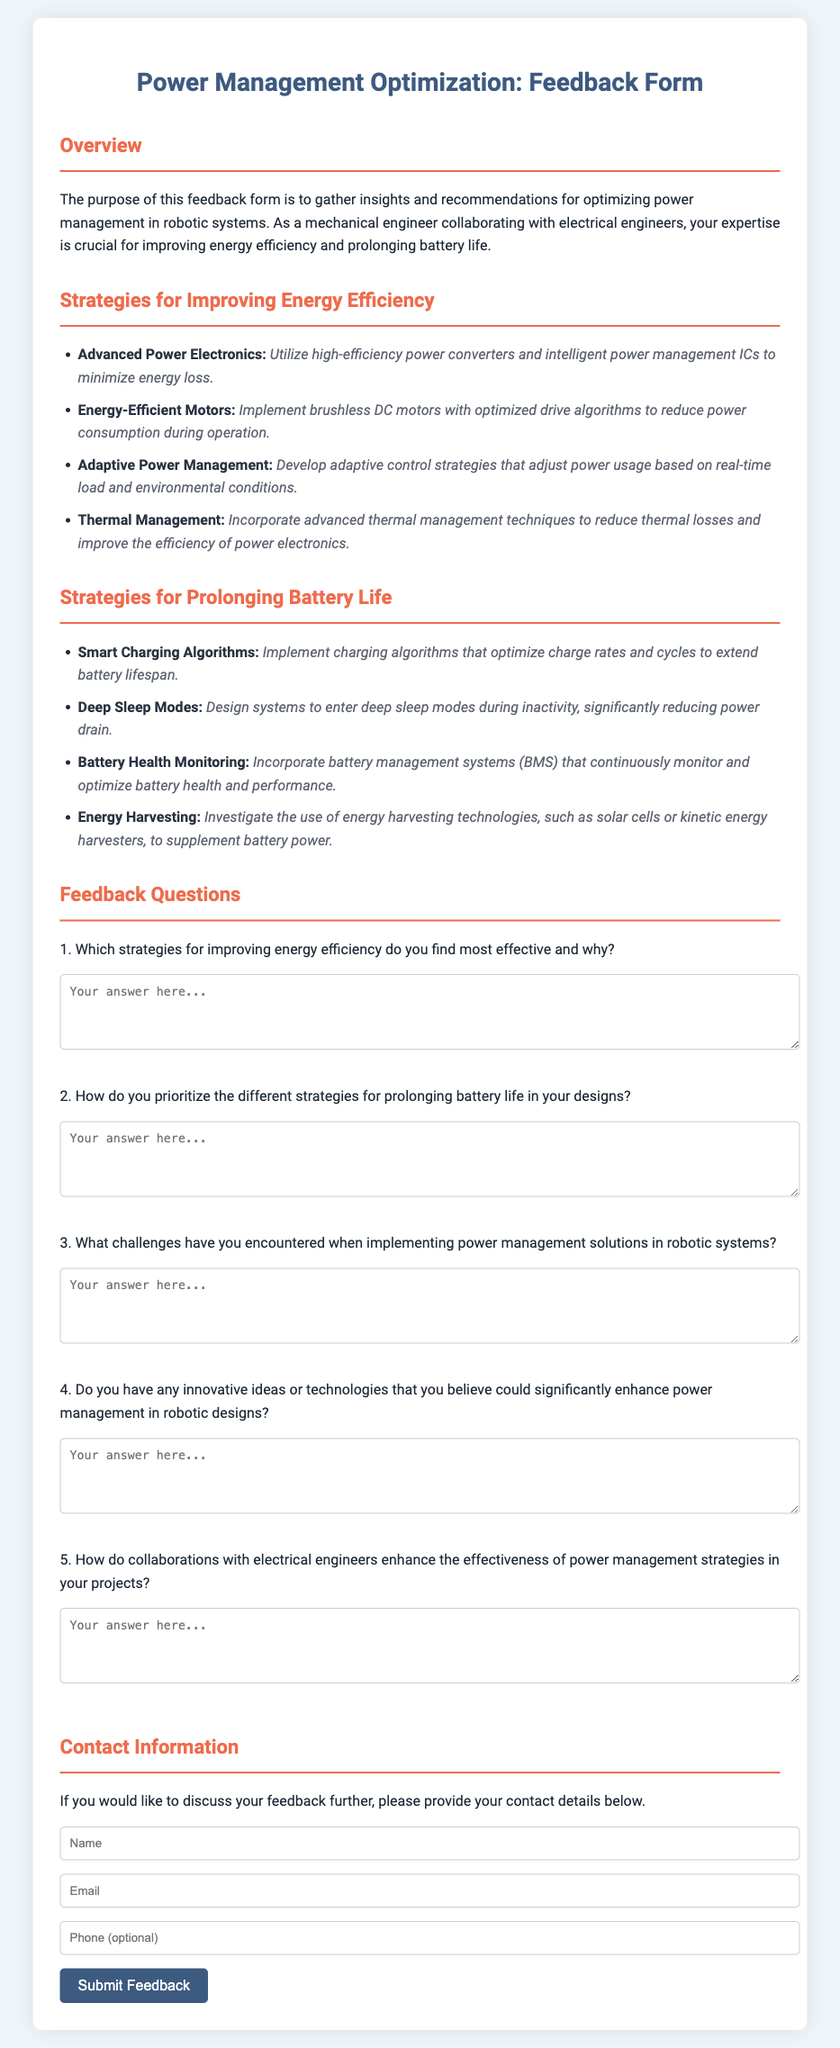What is the title of the document? The title is the main heading that summarizes the content of the document.
Answer: Power Management Optimization: Feedback Form How many strategies are listed for improving energy efficiency? The number of strategies can be counted from the list provided in the document.
Answer: 4 What strategy is used to reduce thermal losses? This refers to a specific technique mentioned in the strategies for improving energy efficiency.
Answer: Thermal Management What does "Smart Charging Algorithms" aim to accomplish? This strategy specifically targets battery lifespan as discussed in the document.
Answer: Extend battery lifespan What is one challenge mentioned when implementing power management solutions? The question seeks to identify potential difficulties outlined in the feedback section.
Answer: (Open for response) How many feedback questions are provided in the document? The total count of the questions seeking input from respondents is specified in the document.
Answer: 5 What is one type of technology suggested for energy harvesting? This asks for an example of strategies provided in the document.
Answer: Solar cells What is the purpose of this feedback form? This is the overarching reason stated in the introduction of the document.
Answer: Gather insights and recommendations What is the background color of the document? This pertains to the style aspect of the document structure.
Answer: #f0f5f9 